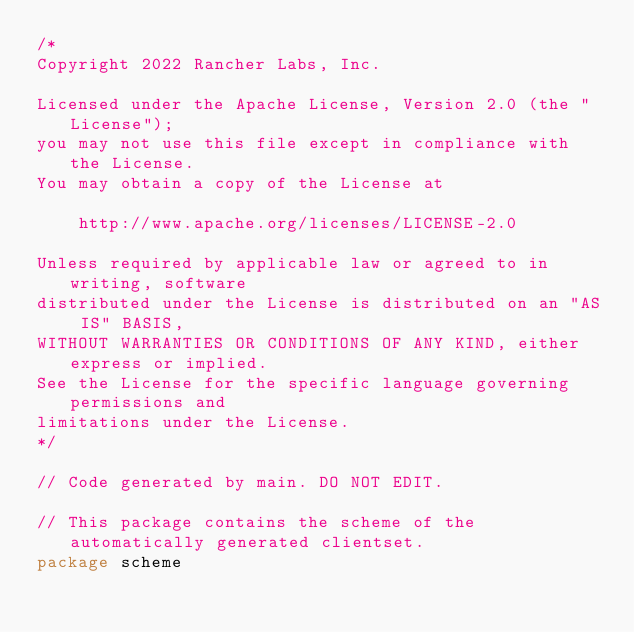<code> <loc_0><loc_0><loc_500><loc_500><_Go_>/*
Copyright 2022 Rancher Labs, Inc.

Licensed under the Apache License, Version 2.0 (the "License");
you may not use this file except in compliance with the License.
You may obtain a copy of the License at

    http://www.apache.org/licenses/LICENSE-2.0

Unless required by applicable law or agreed to in writing, software
distributed under the License is distributed on an "AS IS" BASIS,
WITHOUT WARRANTIES OR CONDITIONS OF ANY KIND, either express or implied.
See the License for the specific language governing permissions and
limitations under the License.
*/

// Code generated by main. DO NOT EDIT.

// This package contains the scheme of the automatically generated clientset.
package scheme
</code> 